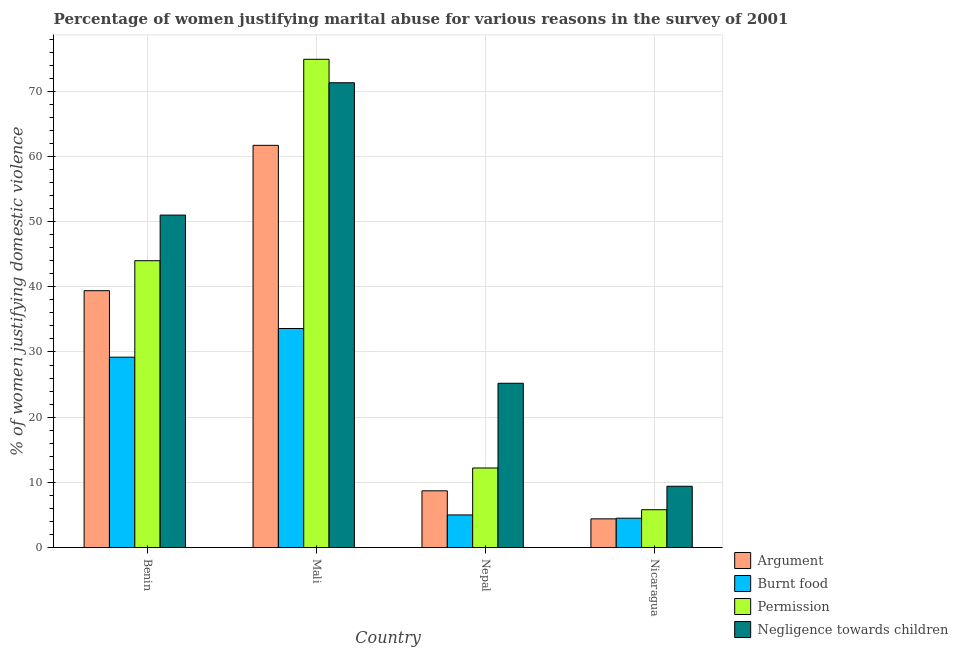Are the number of bars per tick equal to the number of legend labels?
Your response must be concise. Yes. How many bars are there on the 4th tick from the left?
Ensure brevity in your answer.  4. How many bars are there on the 1st tick from the right?
Your answer should be very brief. 4. What is the label of the 4th group of bars from the left?
Offer a terse response. Nicaragua. In how many cases, is the number of bars for a given country not equal to the number of legend labels?
Your response must be concise. 0. What is the percentage of women justifying abuse for showing negligence towards children in Benin?
Provide a short and direct response. 51. Across all countries, what is the maximum percentage of women justifying abuse in the case of an argument?
Provide a short and direct response. 61.7. In which country was the percentage of women justifying abuse for burning food maximum?
Provide a short and direct response. Mali. In which country was the percentage of women justifying abuse for burning food minimum?
Provide a succinct answer. Nicaragua. What is the total percentage of women justifying abuse for showing negligence towards children in the graph?
Your response must be concise. 156.9. What is the difference between the percentage of women justifying abuse for burning food in Benin and that in Mali?
Give a very brief answer. -4.4. What is the difference between the percentage of women justifying abuse in the case of an argument in Nicaragua and the percentage of women justifying abuse for burning food in Nepal?
Your answer should be very brief. -0.6. What is the average percentage of women justifying abuse for showing negligence towards children per country?
Your response must be concise. 39.23. What is the difference between the percentage of women justifying abuse for burning food and percentage of women justifying abuse for showing negligence towards children in Benin?
Your answer should be very brief. -21.8. In how many countries, is the percentage of women justifying abuse for going without permission greater than 76 %?
Make the answer very short. 0. What is the ratio of the percentage of women justifying abuse for burning food in Mali to that in Nepal?
Ensure brevity in your answer.  6.72. Is the difference between the percentage of women justifying abuse for showing negligence towards children in Benin and Mali greater than the difference between the percentage of women justifying abuse for burning food in Benin and Mali?
Keep it short and to the point. No. What is the difference between the highest and the second highest percentage of women justifying abuse in the case of an argument?
Give a very brief answer. 22.3. What is the difference between the highest and the lowest percentage of women justifying abuse in the case of an argument?
Keep it short and to the point. 57.3. What does the 2nd bar from the left in Nepal represents?
Offer a very short reply. Burnt food. What does the 2nd bar from the right in Mali represents?
Ensure brevity in your answer.  Permission. Is it the case that in every country, the sum of the percentage of women justifying abuse in the case of an argument and percentage of women justifying abuse for burning food is greater than the percentage of women justifying abuse for going without permission?
Offer a very short reply. Yes. Are all the bars in the graph horizontal?
Your answer should be compact. No. How many countries are there in the graph?
Your answer should be compact. 4. Does the graph contain any zero values?
Ensure brevity in your answer.  No. Does the graph contain grids?
Keep it short and to the point. Yes. Where does the legend appear in the graph?
Keep it short and to the point. Bottom right. What is the title of the graph?
Your answer should be compact. Percentage of women justifying marital abuse for various reasons in the survey of 2001. Does "WFP" appear as one of the legend labels in the graph?
Your answer should be very brief. No. What is the label or title of the Y-axis?
Offer a terse response. % of women justifying domestic violence. What is the % of women justifying domestic violence in Argument in Benin?
Keep it short and to the point. 39.4. What is the % of women justifying domestic violence of Burnt food in Benin?
Your answer should be very brief. 29.2. What is the % of women justifying domestic violence in Permission in Benin?
Provide a succinct answer. 44. What is the % of women justifying domestic violence in Argument in Mali?
Provide a short and direct response. 61.7. What is the % of women justifying domestic violence in Burnt food in Mali?
Offer a terse response. 33.6. What is the % of women justifying domestic violence of Permission in Mali?
Make the answer very short. 74.9. What is the % of women justifying domestic violence in Negligence towards children in Mali?
Ensure brevity in your answer.  71.3. What is the % of women justifying domestic violence in Argument in Nepal?
Give a very brief answer. 8.7. What is the % of women justifying domestic violence of Burnt food in Nepal?
Give a very brief answer. 5. What is the % of women justifying domestic violence in Permission in Nepal?
Make the answer very short. 12.2. What is the % of women justifying domestic violence of Negligence towards children in Nepal?
Give a very brief answer. 25.2. What is the % of women justifying domestic violence of Burnt food in Nicaragua?
Offer a terse response. 4.5. What is the % of women justifying domestic violence in Permission in Nicaragua?
Make the answer very short. 5.8. Across all countries, what is the maximum % of women justifying domestic violence of Argument?
Make the answer very short. 61.7. Across all countries, what is the maximum % of women justifying domestic violence in Burnt food?
Your response must be concise. 33.6. Across all countries, what is the maximum % of women justifying domestic violence of Permission?
Your answer should be very brief. 74.9. Across all countries, what is the maximum % of women justifying domestic violence in Negligence towards children?
Your response must be concise. 71.3. Across all countries, what is the minimum % of women justifying domestic violence in Argument?
Your answer should be compact. 4.4. Across all countries, what is the minimum % of women justifying domestic violence of Burnt food?
Make the answer very short. 4.5. Across all countries, what is the minimum % of women justifying domestic violence of Negligence towards children?
Offer a very short reply. 9.4. What is the total % of women justifying domestic violence of Argument in the graph?
Provide a short and direct response. 114.2. What is the total % of women justifying domestic violence of Burnt food in the graph?
Keep it short and to the point. 72.3. What is the total % of women justifying domestic violence in Permission in the graph?
Provide a short and direct response. 136.9. What is the total % of women justifying domestic violence in Negligence towards children in the graph?
Provide a succinct answer. 156.9. What is the difference between the % of women justifying domestic violence in Argument in Benin and that in Mali?
Your response must be concise. -22.3. What is the difference between the % of women justifying domestic violence of Permission in Benin and that in Mali?
Give a very brief answer. -30.9. What is the difference between the % of women justifying domestic violence of Negligence towards children in Benin and that in Mali?
Your response must be concise. -20.3. What is the difference between the % of women justifying domestic violence in Argument in Benin and that in Nepal?
Keep it short and to the point. 30.7. What is the difference between the % of women justifying domestic violence of Burnt food in Benin and that in Nepal?
Your answer should be compact. 24.2. What is the difference between the % of women justifying domestic violence of Permission in Benin and that in Nepal?
Your answer should be very brief. 31.8. What is the difference between the % of women justifying domestic violence in Negligence towards children in Benin and that in Nepal?
Offer a very short reply. 25.8. What is the difference between the % of women justifying domestic violence of Burnt food in Benin and that in Nicaragua?
Provide a short and direct response. 24.7. What is the difference between the % of women justifying domestic violence in Permission in Benin and that in Nicaragua?
Keep it short and to the point. 38.2. What is the difference between the % of women justifying domestic violence of Negligence towards children in Benin and that in Nicaragua?
Your answer should be very brief. 41.6. What is the difference between the % of women justifying domestic violence in Argument in Mali and that in Nepal?
Provide a short and direct response. 53. What is the difference between the % of women justifying domestic violence in Burnt food in Mali and that in Nepal?
Offer a very short reply. 28.6. What is the difference between the % of women justifying domestic violence of Permission in Mali and that in Nepal?
Provide a succinct answer. 62.7. What is the difference between the % of women justifying domestic violence in Negligence towards children in Mali and that in Nepal?
Provide a succinct answer. 46.1. What is the difference between the % of women justifying domestic violence of Argument in Mali and that in Nicaragua?
Provide a succinct answer. 57.3. What is the difference between the % of women justifying domestic violence of Burnt food in Mali and that in Nicaragua?
Offer a terse response. 29.1. What is the difference between the % of women justifying domestic violence of Permission in Mali and that in Nicaragua?
Your answer should be compact. 69.1. What is the difference between the % of women justifying domestic violence of Negligence towards children in Mali and that in Nicaragua?
Offer a very short reply. 61.9. What is the difference between the % of women justifying domestic violence in Permission in Nepal and that in Nicaragua?
Provide a succinct answer. 6.4. What is the difference between the % of women justifying domestic violence of Argument in Benin and the % of women justifying domestic violence of Burnt food in Mali?
Keep it short and to the point. 5.8. What is the difference between the % of women justifying domestic violence in Argument in Benin and the % of women justifying domestic violence in Permission in Mali?
Provide a short and direct response. -35.5. What is the difference between the % of women justifying domestic violence in Argument in Benin and the % of women justifying domestic violence in Negligence towards children in Mali?
Provide a short and direct response. -31.9. What is the difference between the % of women justifying domestic violence in Burnt food in Benin and the % of women justifying domestic violence in Permission in Mali?
Provide a succinct answer. -45.7. What is the difference between the % of women justifying domestic violence in Burnt food in Benin and the % of women justifying domestic violence in Negligence towards children in Mali?
Provide a succinct answer. -42.1. What is the difference between the % of women justifying domestic violence of Permission in Benin and the % of women justifying domestic violence of Negligence towards children in Mali?
Make the answer very short. -27.3. What is the difference between the % of women justifying domestic violence in Argument in Benin and the % of women justifying domestic violence in Burnt food in Nepal?
Make the answer very short. 34.4. What is the difference between the % of women justifying domestic violence in Argument in Benin and the % of women justifying domestic violence in Permission in Nepal?
Your answer should be compact. 27.2. What is the difference between the % of women justifying domestic violence of Argument in Benin and the % of women justifying domestic violence of Negligence towards children in Nepal?
Give a very brief answer. 14.2. What is the difference between the % of women justifying domestic violence in Burnt food in Benin and the % of women justifying domestic violence in Negligence towards children in Nepal?
Make the answer very short. 4. What is the difference between the % of women justifying domestic violence of Permission in Benin and the % of women justifying domestic violence of Negligence towards children in Nepal?
Your answer should be compact. 18.8. What is the difference between the % of women justifying domestic violence of Argument in Benin and the % of women justifying domestic violence of Burnt food in Nicaragua?
Give a very brief answer. 34.9. What is the difference between the % of women justifying domestic violence of Argument in Benin and the % of women justifying domestic violence of Permission in Nicaragua?
Your answer should be very brief. 33.6. What is the difference between the % of women justifying domestic violence of Argument in Benin and the % of women justifying domestic violence of Negligence towards children in Nicaragua?
Provide a short and direct response. 30. What is the difference between the % of women justifying domestic violence of Burnt food in Benin and the % of women justifying domestic violence of Permission in Nicaragua?
Give a very brief answer. 23.4. What is the difference between the % of women justifying domestic violence in Burnt food in Benin and the % of women justifying domestic violence in Negligence towards children in Nicaragua?
Give a very brief answer. 19.8. What is the difference between the % of women justifying domestic violence of Permission in Benin and the % of women justifying domestic violence of Negligence towards children in Nicaragua?
Ensure brevity in your answer.  34.6. What is the difference between the % of women justifying domestic violence of Argument in Mali and the % of women justifying domestic violence of Burnt food in Nepal?
Make the answer very short. 56.7. What is the difference between the % of women justifying domestic violence of Argument in Mali and the % of women justifying domestic violence of Permission in Nepal?
Offer a terse response. 49.5. What is the difference between the % of women justifying domestic violence in Argument in Mali and the % of women justifying domestic violence in Negligence towards children in Nepal?
Your answer should be compact. 36.5. What is the difference between the % of women justifying domestic violence in Burnt food in Mali and the % of women justifying domestic violence in Permission in Nepal?
Give a very brief answer. 21.4. What is the difference between the % of women justifying domestic violence in Burnt food in Mali and the % of women justifying domestic violence in Negligence towards children in Nepal?
Provide a short and direct response. 8.4. What is the difference between the % of women justifying domestic violence in Permission in Mali and the % of women justifying domestic violence in Negligence towards children in Nepal?
Provide a short and direct response. 49.7. What is the difference between the % of women justifying domestic violence in Argument in Mali and the % of women justifying domestic violence in Burnt food in Nicaragua?
Provide a short and direct response. 57.2. What is the difference between the % of women justifying domestic violence in Argument in Mali and the % of women justifying domestic violence in Permission in Nicaragua?
Your answer should be very brief. 55.9. What is the difference between the % of women justifying domestic violence in Argument in Mali and the % of women justifying domestic violence in Negligence towards children in Nicaragua?
Provide a short and direct response. 52.3. What is the difference between the % of women justifying domestic violence in Burnt food in Mali and the % of women justifying domestic violence in Permission in Nicaragua?
Give a very brief answer. 27.8. What is the difference between the % of women justifying domestic violence of Burnt food in Mali and the % of women justifying domestic violence of Negligence towards children in Nicaragua?
Your response must be concise. 24.2. What is the difference between the % of women justifying domestic violence in Permission in Mali and the % of women justifying domestic violence in Negligence towards children in Nicaragua?
Provide a succinct answer. 65.5. What is the difference between the % of women justifying domestic violence in Argument in Nepal and the % of women justifying domestic violence in Burnt food in Nicaragua?
Your response must be concise. 4.2. What is the difference between the % of women justifying domestic violence of Burnt food in Nepal and the % of women justifying domestic violence of Negligence towards children in Nicaragua?
Offer a terse response. -4.4. What is the average % of women justifying domestic violence of Argument per country?
Make the answer very short. 28.55. What is the average % of women justifying domestic violence in Burnt food per country?
Make the answer very short. 18.07. What is the average % of women justifying domestic violence in Permission per country?
Provide a succinct answer. 34.23. What is the average % of women justifying domestic violence of Negligence towards children per country?
Give a very brief answer. 39.23. What is the difference between the % of women justifying domestic violence of Argument and % of women justifying domestic violence of Negligence towards children in Benin?
Provide a succinct answer. -11.6. What is the difference between the % of women justifying domestic violence of Burnt food and % of women justifying domestic violence of Permission in Benin?
Give a very brief answer. -14.8. What is the difference between the % of women justifying domestic violence in Burnt food and % of women justifying domestic violence in Negligence towards children in Benin?
Your answer should be very brief. -21.8. What is the difference between the % of women justifying domestic violence of Argument and % of women justifying domestic violence of Burnt food in Mali?
Make the answer very short. 28.1. What is the difference between the % of women justifying domestic violence of Argument and % of women justifying domestic violence of Permission in Mali?
Ensure brevity in your answer.  -13.2. What is the difference between the % of women justifying domestic violence of Argument and % of women justifying domestic violence of Negligence towards children in Mali?
Your answer should be very brief. -9.6. What is the difference between the % of women justifying domestic violence of Burnt food and % of women justifying domestic violence of Permission in Mali?
Your answer should be compact. -41.3. What is the difference between the % of women justifying domestic violence of Burnt food and % of women justifying domestic violence of Negligence towards children in Mali?
Provide a succinct answer. -37.7. What is the difference between the % of women justifying domestic violence in Argument and % of women justifying domestic violence in Burnt food in Nepal?
Keep it short and to the point. 3.7. What is the difference between the % of women justifying domestic violence in Argument and % of women justifying domestic violence in Negligence towards children in Nepal?
Keep it short and to the point. -16.5. What is the difference between the % of women justifying domestic violence of Burnt food and % of women justifying domestic violence of Negligence towards children in Nepal?
Offer a terse response. -20.2. What is the difference between the % of women justifying domestic violence in Permission and % of women justifying domestic violence in Negligence towards children in Nepal?
Ensure brevity in your answer.  -13. What is the difference between the % of women justifying domestic violence of Argument and % of women justifying domestic violence of Permission in Nicaragua?
Your answer should be compact. -1.4. What is the difference between the % of women justifying domestic violence of Argument and % of women justifying domestic violence of Negligence towards children in Nicaragua?
Your answer should be very brief. -5. What is the difference between the % of women justifying domestic violence in Permission and % of women justifying domestic violence in Negligence towards children in Nicaragua?
Give a very brief answer. -3.6. What is the ratio of the % of women justifying domestic violence in Argument in Benin to that in Mali?
Provide a short and direct response. 0.64. What is the ratio of the % of women justifying domestic violence in Burnt food in Benin to that in Mali?
Keep it short and to the point. 0.87. What is the ratio of the % of women justifying domestic violence of Permission in Benin to that in Mali?
Your answer should be compact. 0.59. What is the ratio of the % of women justifying domestic violence of Negligence towards children in Benin to that in Mali?
Make the answer very short. 0.72. What is the ratio of the % of women justifying domestic violence of Argument in Benin to that in Nepal?
Make the answer very short. 4.53. What is the ratio of the % of women justifying domestic violence in Burnt food in Benin to that in Nepal?
Provide a succinct answer. 5.84. What is the ratio of the % of women justifying domestic violence in Permission in Benin to that in Nepal?
Ensure brevity in your answer.  3.61. What is the ratio of the % of women justifying domestic violence of Negligence towards children in Benin to that in Nepal?
Your answer should be compact. 2.02. What is the ratio of the % of women justifying domestic violence of Argument in Benin to that in Nicaragua?
Ensure brevity in your answer.  8.95. What is the ratio of the % of women justifying domestic violence in Burnt food in Benin to that in Nicaragua?
Ensure brevity in your answer.  6.49. What is the ratio of the % of women justifying domestic violence of Permission in Benin to that in Nicaragua?
Give a very brief answer. 7.59. What is the ratio of the % of women justifying domestic violence in Negligence towards children in Benin to that in Nicaragua?
Offer a terse response. 5.43. What is the ratio of the % of women justifying domestic violence in Argument in Mali to that in Nepal?
Your answer should be compact. 7.09. What is the ratio of the % of women justifying domestic violence of Burnt food in Mali to that in Nepal?
Keep it short and to the point. 6.72. What is the ratio of the % of women justifying domestic violence in Permission in Mali to that in Nepal?
Offer a terse response. 6.14. What is the ratio of the % of women justifying domestic violence of Negligence towards children in Mali to that in Nepal?
Your response must be concise. 2.83. What is the ratio of the % of women justifying domestic violence in Argument in Mali to that in Nicaragua?
Ensure brevity in your answer.  14.02. What is the ratio of the % of women justifying domestic violence in Burnt food in Mali to that in Nicaragua?
Keep it short and to the point. 7.47. What is the ratio of the % of women justifying domestic violence of Permission in Mali to that in Nicaragua?
Your answer should be compact. 12.91. What is the ratio of the % of women justifying domestic violence in Negligence towards children in Mali to that in Nicaragua?
Make the answer very short. 7.59. What is the ratio of the % of women justifying domestic violence in Argument in Nepal to that in Nicaragua?
Offer a terse response. 1.98. What is the ratio of the % of women justifying domestic violence of Burnt food in Nepal to that in Nicaragua?
Keep it short and to the point. 1.11. What is the ratio of the % of women justifying domestic violence of Permission in Nepal to that in Nicaragua?
Provide a short and direct response. 2.1. What is the ratio of the % of women justifying domestic violence in Negligence towards children in Nepal to that in Nicaragua?
Keep it short and to the point. 2.68. What is the difference between the highest and the second highest % of women justifying domestic violence of Argument?
Provide a short and direct response. 22.3. What is the difference between the highest and the second highest % of women justifying domestic violence of Burnt food?
Give a very brief answer. 4.4. What is the difference between the highest and the second highest % of women justifying domestic violence in Permission?
Give a very brief answer. 30.9. What is the difference between the highest and the second highest % of women justifying domestic violence of Negligence towards children?
Keep it short and to the point. 20.3. What is the difference between the highest and the lowest % of women justifying domestic violence in Argument?
Offer a terse response. 57.3. What is the difference between the highest and the lowest % of women justifying domestic violence in Burnt food?
Give a very brief answer. 29.1. What is the difference between the highest and the lowest % of women justifying domestic violence in Permission?
Provide a short and direct response. 69.1. What is the difference between the highest and the lowest % of women justifying domestic violence in Negligence towards children?
Give a very brief answer. 61.9. 